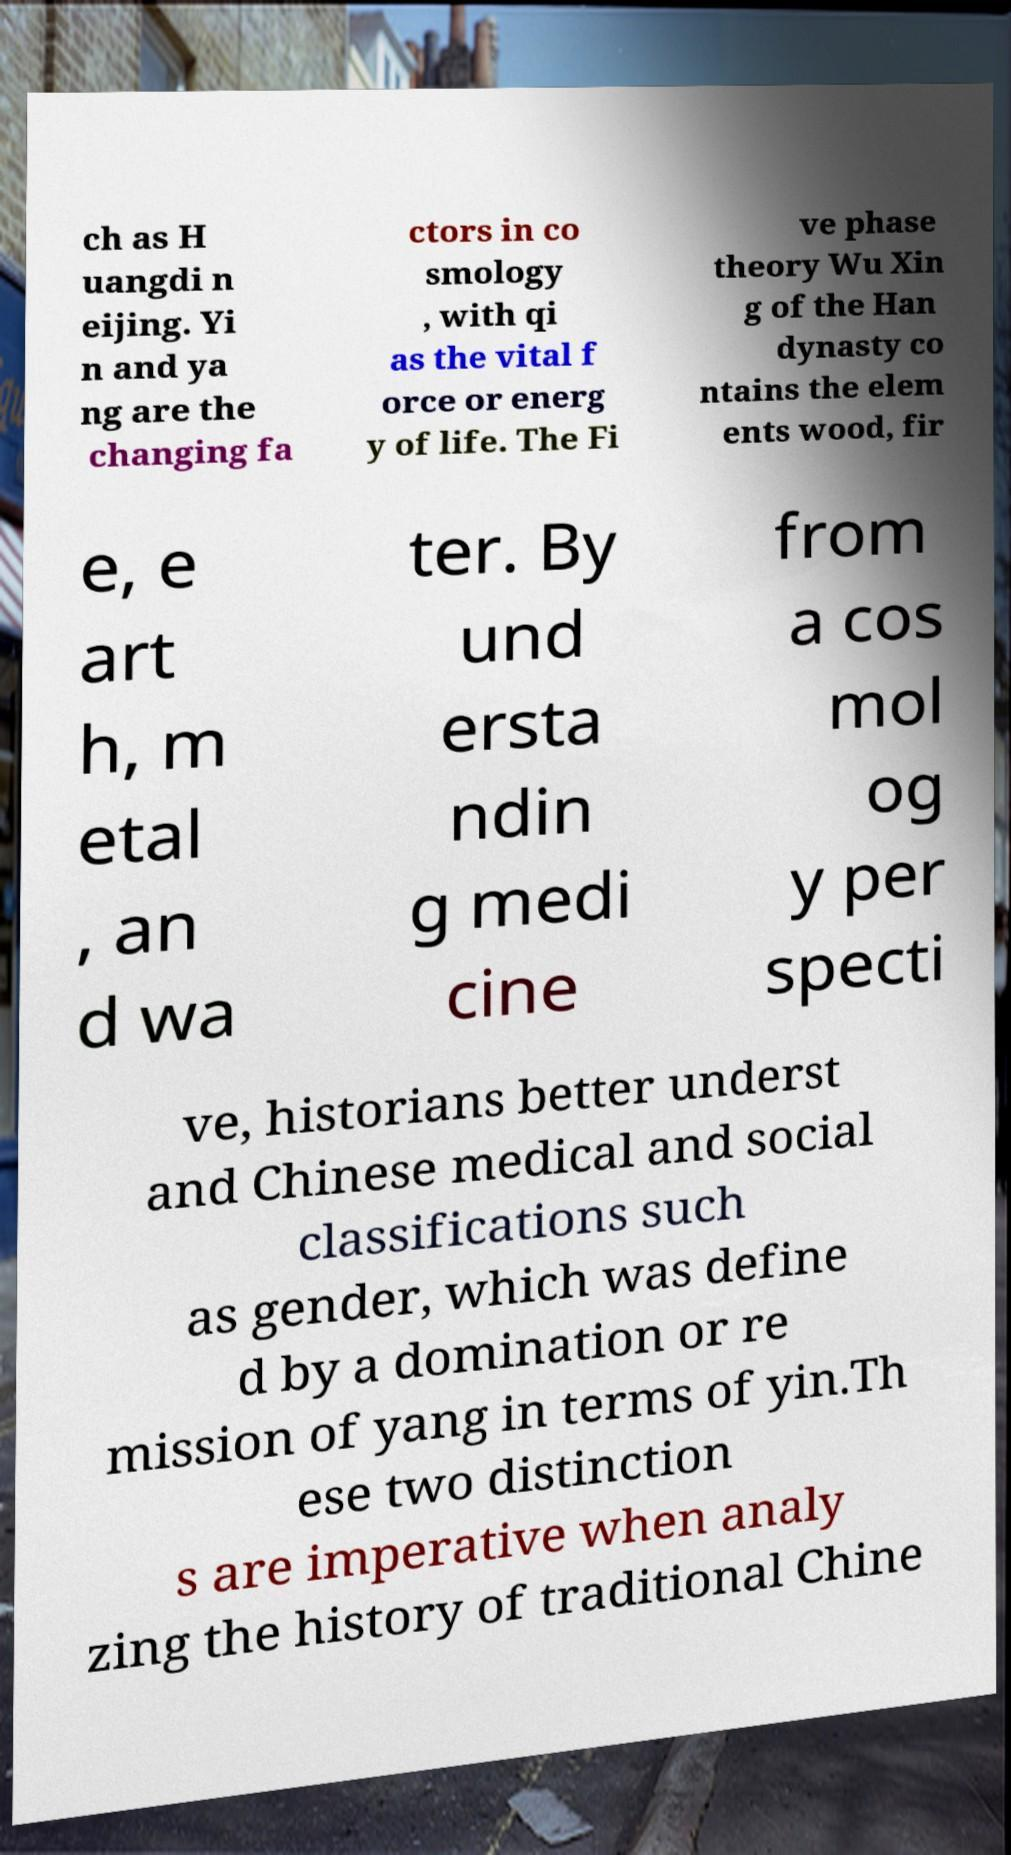There's text embedded in this image that I need extracted. Can you transcribe it verbatim? ch as H uangdi n eijing. Yi n and ya ng are the changing fa ctors in co smology , with qi as the vital f orce or energ y of life. The Fi ve phase theory Wu Xin g of the Han dynasty co ntains the elem ents wood, fir e, e art h, m etal , an d wa ter. By und ersta ndin g medi cine from a cos mol og y per specti ve, historians better underst and Chinese medical and social classifications such as gender, which was define d by a domination or re mission of yang in terms of yin.Th ese two distinction s are imperative when analy zing the history of traditional Chine 